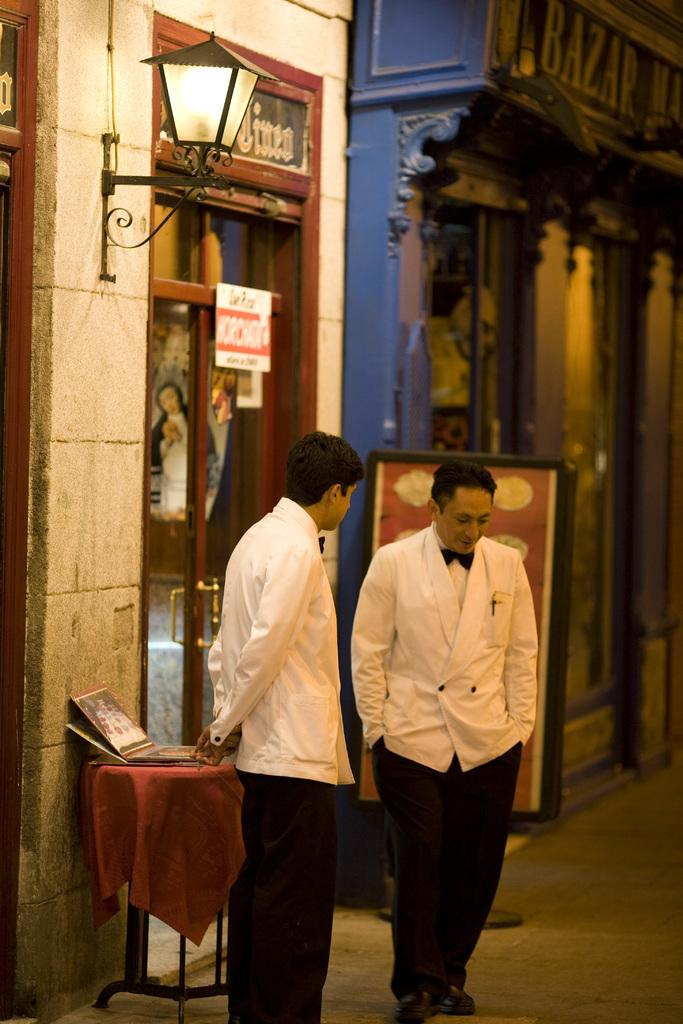How many people are in the image? There are two men in the image. What type of clothing are the men wearing? The men are wearing trousers and coats. What object can be seen in the image? There is a lamp in the image. What type of location might the image depict? The image appears to depict a store. What type of cough medicine is on display in the image? There is no cough medicine present in the image. How many members are in the team depicted in the image? There is no team present in the image; it features two men. 